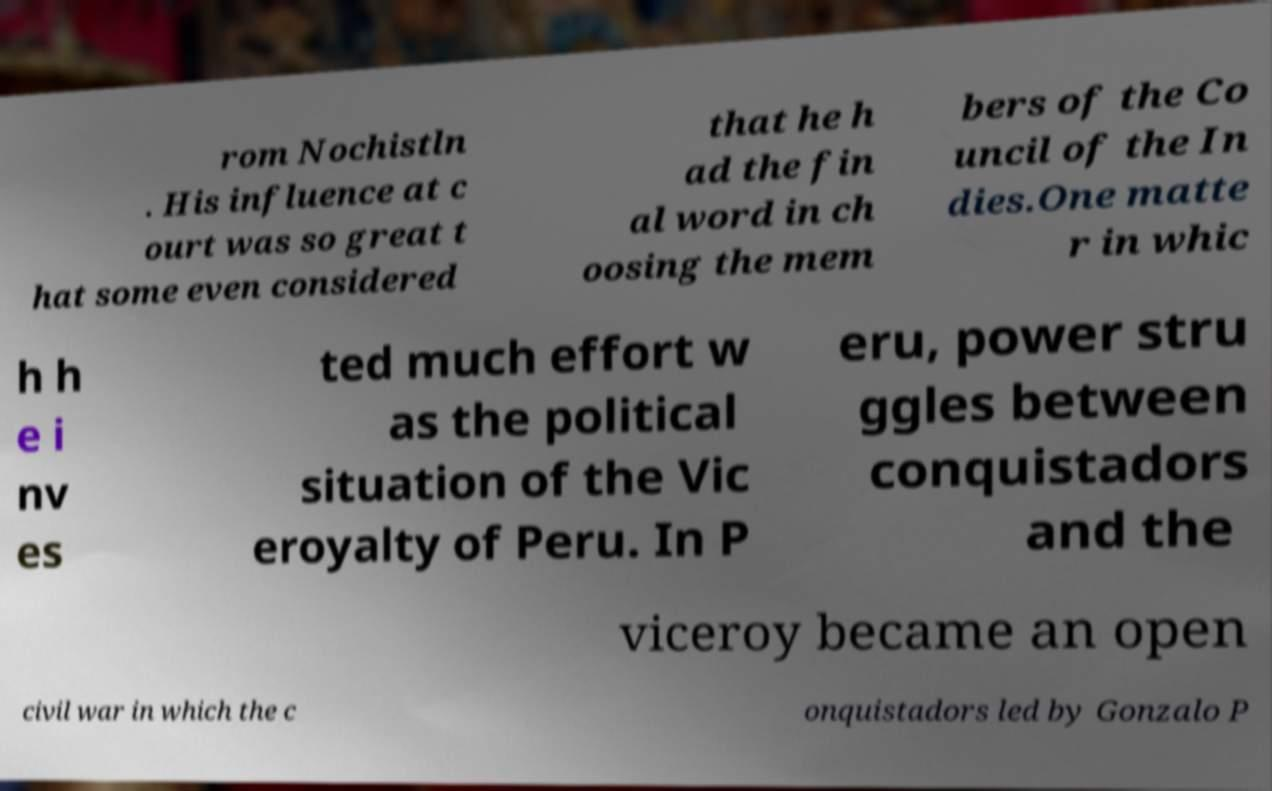I need the written content from this picture converted into text. Can you do that? rom Nochistln . His influence at c ourt was so great t hat some even considered that he h ad the fin al word in ch oosing the mem bers of the Co uncil of the In dies.One matte r in whic h h e i nv es ted much effort w as the political situation of the Vic eroyalty of Peru. In P eru, power stru ggles between conquistadors and the viceroy became an open civil war in which the c onquistadors led by Gonzalo P 